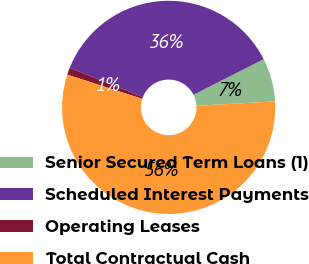Convert chart. <chart><loc_0><loc_0><loc_500><loc_500><pie_chart><fcel>Senior Secured Term Loans (1)<fcel>Scheduled Interest Payments<fcel>Operating Leases<fcel>Total Contractual Cash<nl><fcel>6.57%<fcel>36.47%<fcel>1.09%<fcel>55.87%<nl></chart> 